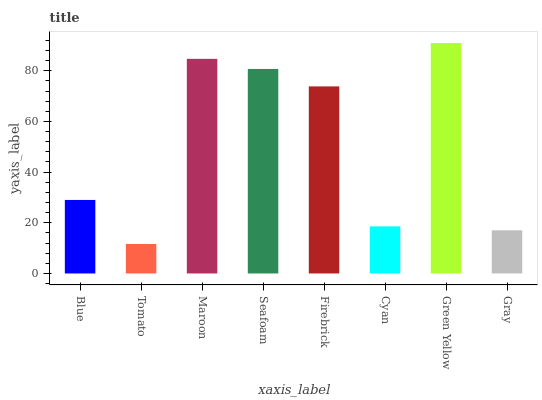Is Tomato the minimum?
Answer yes or no. Yes. Is Green Yellow the maximum?
Answer yes or no. Yes. Is Maroon the minimum?
Answer yes or no. No. Is Maroon the maximum?
Answer yes or no. No. Is Maroon greater than Tomato?
Answer yes or no. Yes. Is Tomato less than Maroon?
Answer yes or no. Yes. Is Tomato greater than Maroon?
Answer yes or no. No. Is Maroon less than Tomato?
Answer yes or no. No. Is Firebrick the high median?
Answer yes or no. Yes. Is Blue the low median?
Answer yes or no. Yes. Is Maroon the high median?
Answer yes or no. No. Is Maroon the low median?
Answer yes or no. No. 